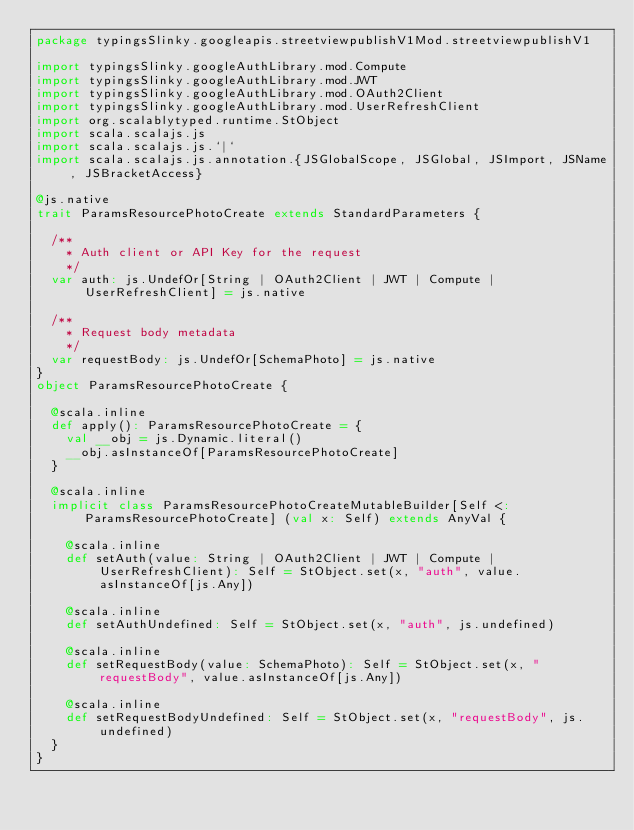Convert code to text. <code><loc_0><loc_0><loc_500><loc_500><_Scala_>package typingsSlinky.googleapis.streetviewpublishV1Mod.streetviewpublishV1

import typingsSlinky.googleAuthLibrary.mod.Compute
import typingsSlinky.googleAuthLibrary.mod.JWT
import typingsSlinky.googleAuthLibrary.mod.OAuth2Client
import typingsSlinky.googleAuthLibrary.mod.UserRefreshClient
import org.scalablytyped.runtime.StObject
import scala.scalajs.js
import scala.scalajs.js.`|`
import scala.scalajs.js.annotation.{JSGlobalScope, JSGlobal, JSImport, JSName, JSBracketAccess}

@js.native
trait ParamsResourcePhotoCreate extends StandardParameters {
  
  /**
    * Auth client or API Key for the request
    */
  var auth: js.UndefOr[String | OAuth2Client | JWT | Compute | UserRefreshClient] = js.native
  
  /**
    * Request body metadata
    */
  var requestBody: js.UndefOr[SchemaPhoto] = js.native
}
object ParamsResourcePhotoCreate {
  
  @scala.inline
  def apply(): ParamsResourcePhotoCreate = {
    val __obj = js.Dynamic.literal()
    __obj.asInstanceOf[ParamsResourcePhotoCreate]
  }
  
  @scala.inline
  implicit class ParamsResourcePhotoCreateMutableBuilder[Self <: ParamsResourcePhotoCreate] (val x: Self) extends AnyVal {
    
    @scala.inline
    def setAuth(value: String | OAuth2Client | JWT | Compute | UserRefreshClient): Self = StObject.set(x, "auth", value.asInstanceOf[js.Any])
    
    @scala.inline
    def setAuthUndefined: Self = StObject.set(x, "auth", js.undefined)
    
    @scala.inline
    def setRequestBody(value: SchemaPhoto): Self = StObject.set(x, "requestBody", value.asInstanceOf[js.Any])
    
    @scala.inline
    def setRequestBodyUndefined: Self = StObject.set(x, "requestBody", js.undefined)
  }
}
</code> 